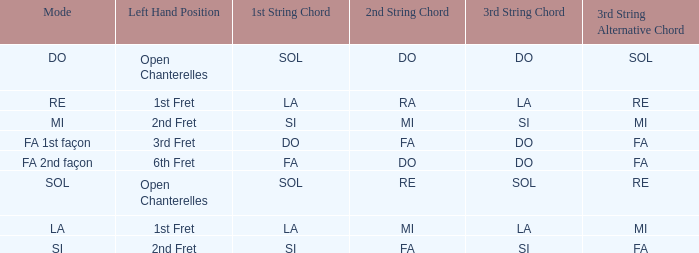For the 2nd string of Do and an Accord du 1st string of FA what is the Depart de la main gauche? 6th case. 